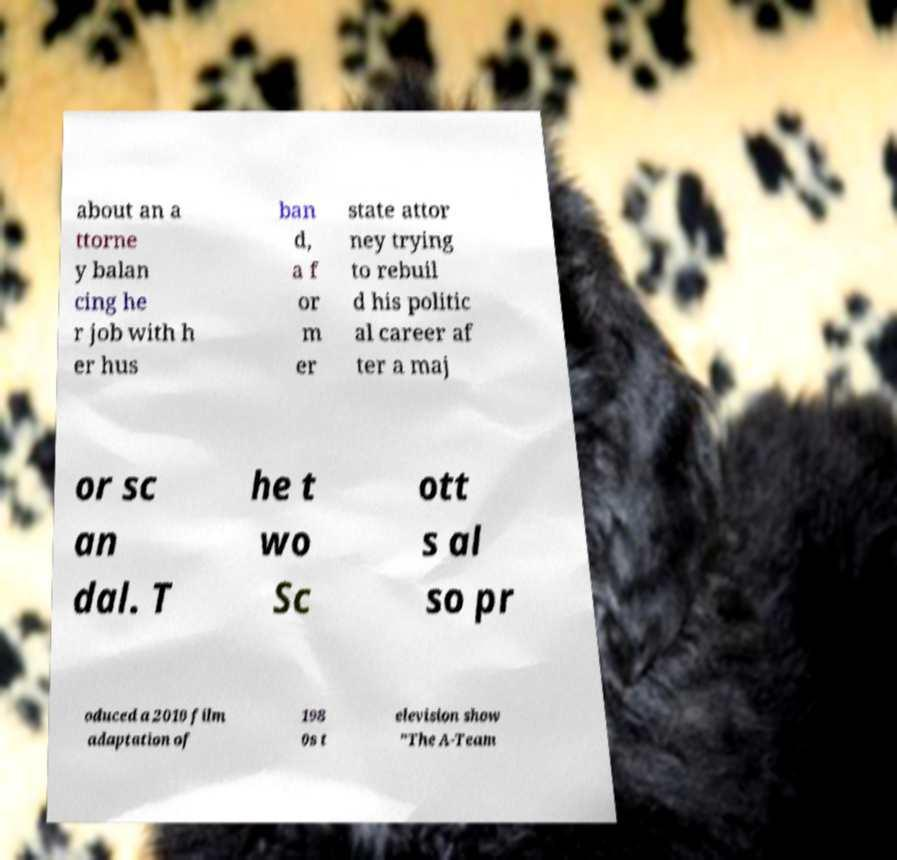Please identify and transcribe the text found in this image. about an a ttorne y balan cing he r job with h er hus ban d, a f or m er state attor ney trying to rebuil d his politic al career af ter a maj or sc an dal. T he t wo Sc ott s al so pr oduced a 2010 film adaptation of 198 0s t elevision show "The A-Team 